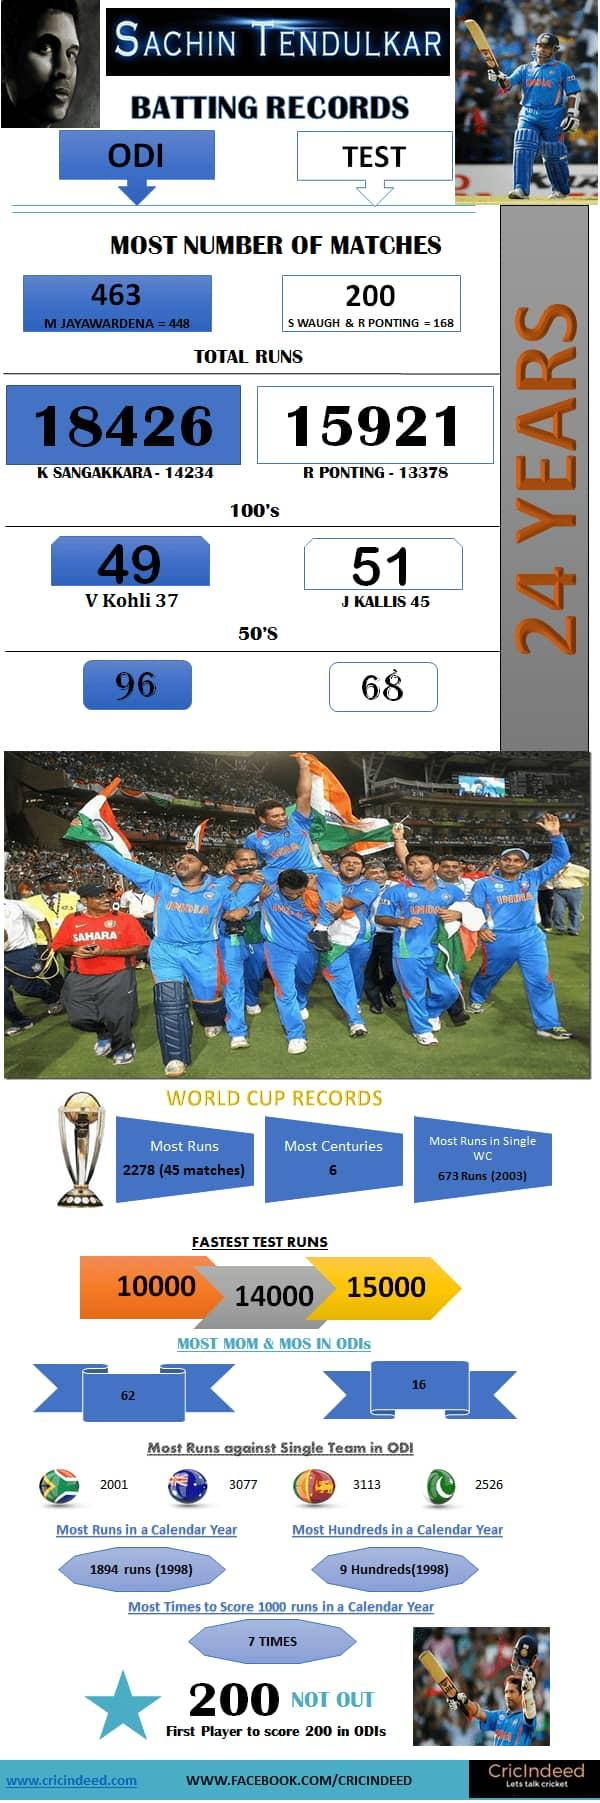Give some essential details in this illustration. Indian cricketer Virat Kohli has the second-highest number of 100's in One Day International matches. Kumar Sangakkara holds the second-highest total runs in One Day International matches, making him a notable player in the cricketing world. Steve Waugh and Ricky Ponting hold the record for the second-highest number of test matches played, each boasting a impressive record of achievement in the sport. J Kallis holds the second-highest number of 100's in test matches. Ricky Ponting is the player who has the second-highest total number of runs in test matches. 